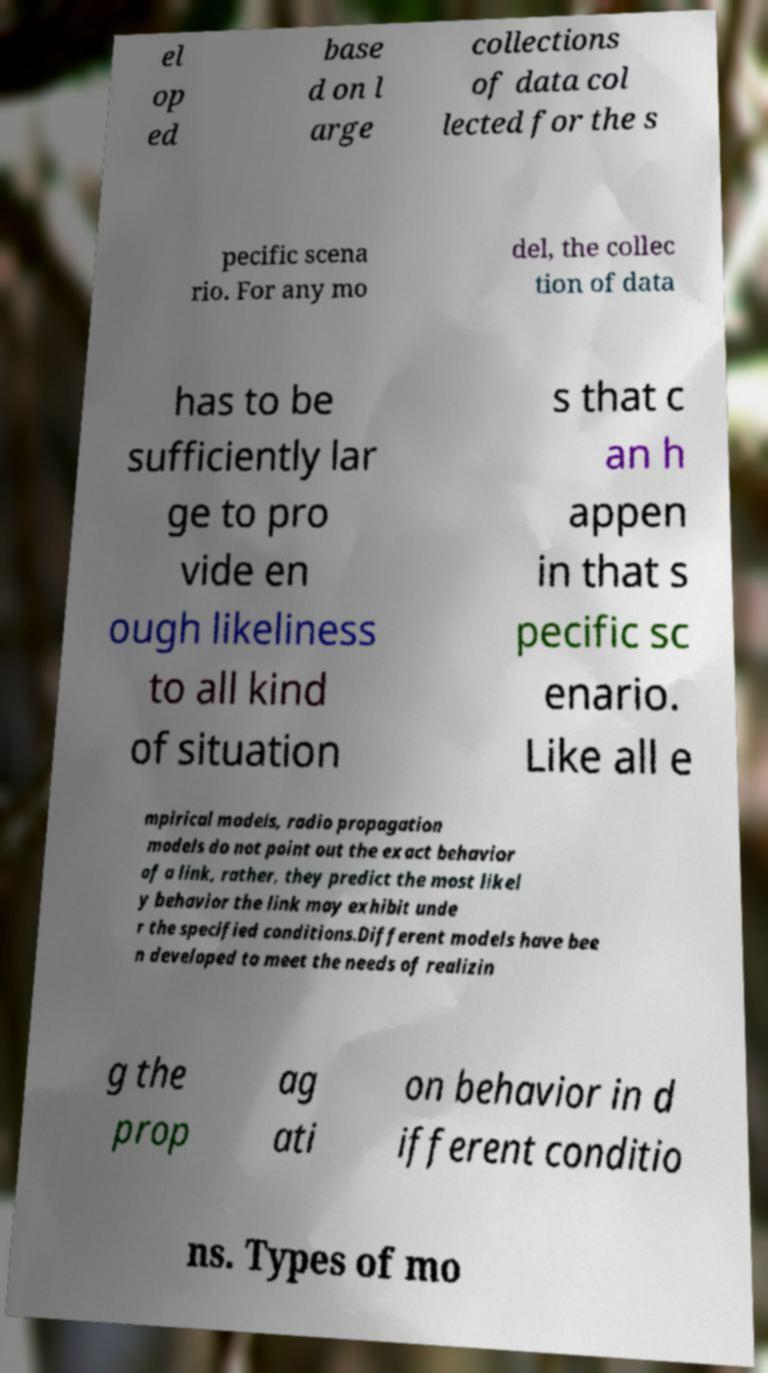I need the written content from this picture converted into text. Can you do that? el op ed base d on l arge collections of data col lected for the s pecific scena rio. For any mo del, the collec tion of data has to be sufficiently lar ge to pro vide en ough likeliness to all kind of situation s that c an h appen in that s pecific sc enario. Like all e mpirical models, radio propagation models do not point out the exact behavior of a link, rather, they predict the most likel y behavior the link may exhibit unde r the specified conditions.Different models have bee n developed to meet the needs of realizin g the prop ag ati on behavior in d ifferent conditio ns. Types of mo 